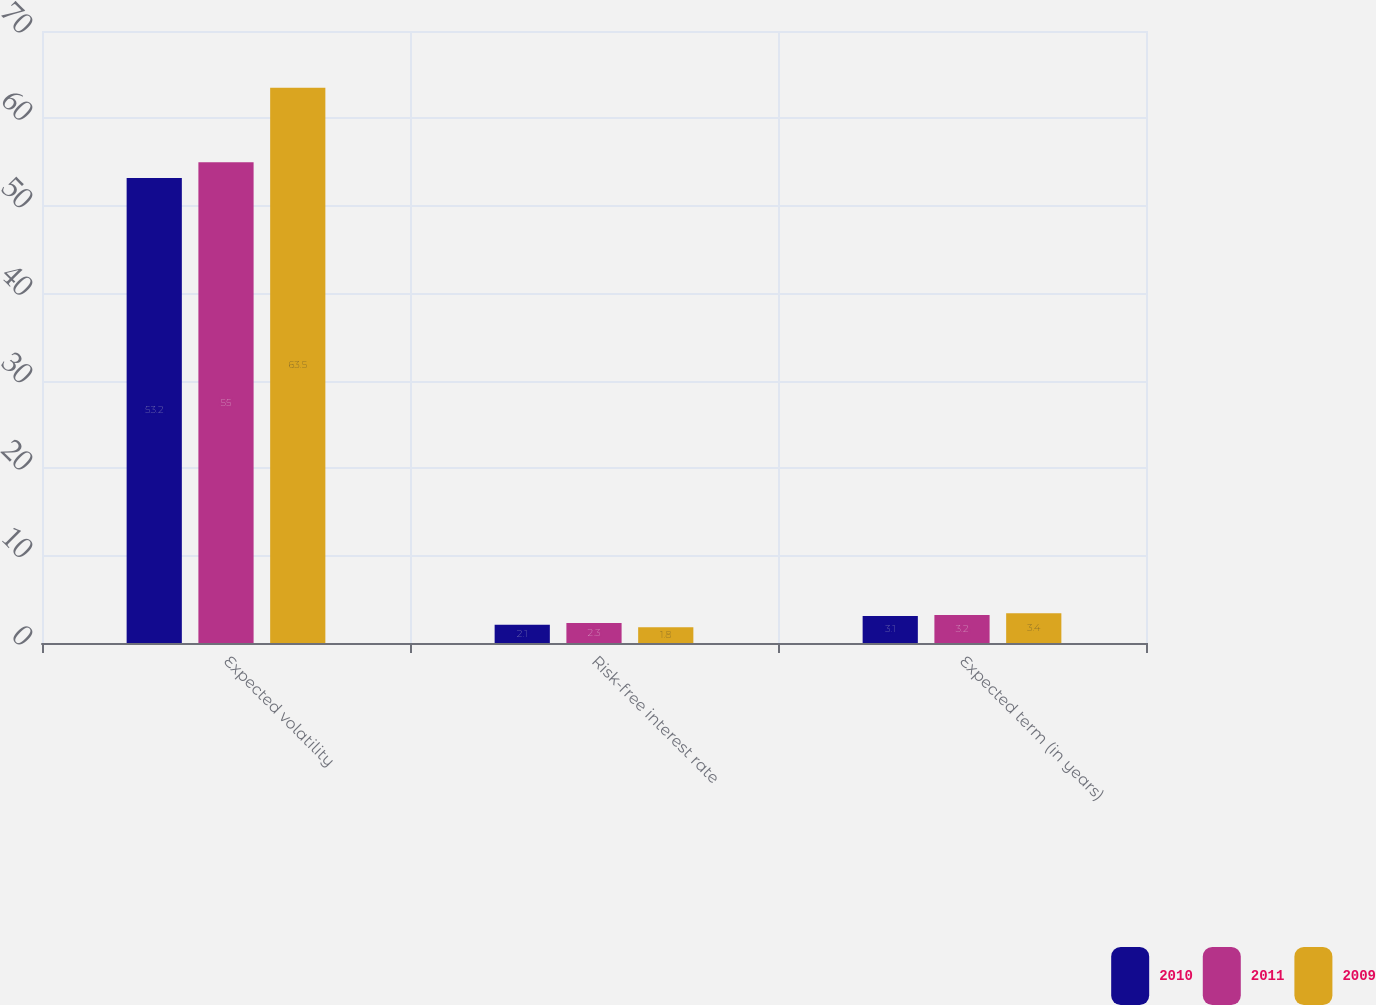Convert chart. <chart><loc_0><loc_0><loc_500><loc_500><stacked_bar_chart><ecel><fcel>Expected volatility<fcel>Risk-free interest rate<fcel>Expected term (in years)<nl><fcel>2010<fcel>53.2<fcel>2.1<fcel>3.1<nl><fcel>2011<fcel>55<fcel>2.3<fcel>3.2<nl><fcel>2009<fcel>63.5<fcel>1.8<fcel>3.4<nl></chart> 